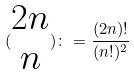Convert formula to latex. <formula><loc_0><loc_0><loc_500><loc_500>( \begin{matrix} 2 n \\ n \end{matrix} ) \colon = \frac { ( 2 n ) ! } { ( n ! ) ^ { 2 } }</formula> 